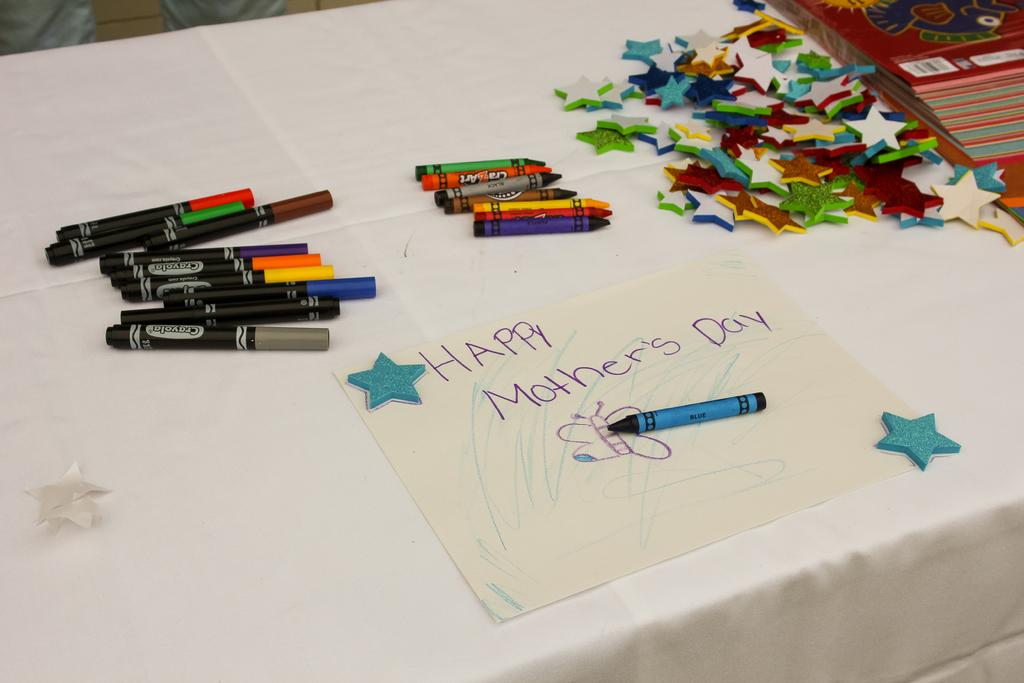What types of writing instruments are visible in the image? There are pens and crayons in the image. What other items can be seen in the image? There are stars, paper, and books in the image. Where are these items located? All these items are placed on a table. What type of underwear is being used as a tablecloth in the image? There is no underwear present in the image, nor is it being used as a tablecloth. 